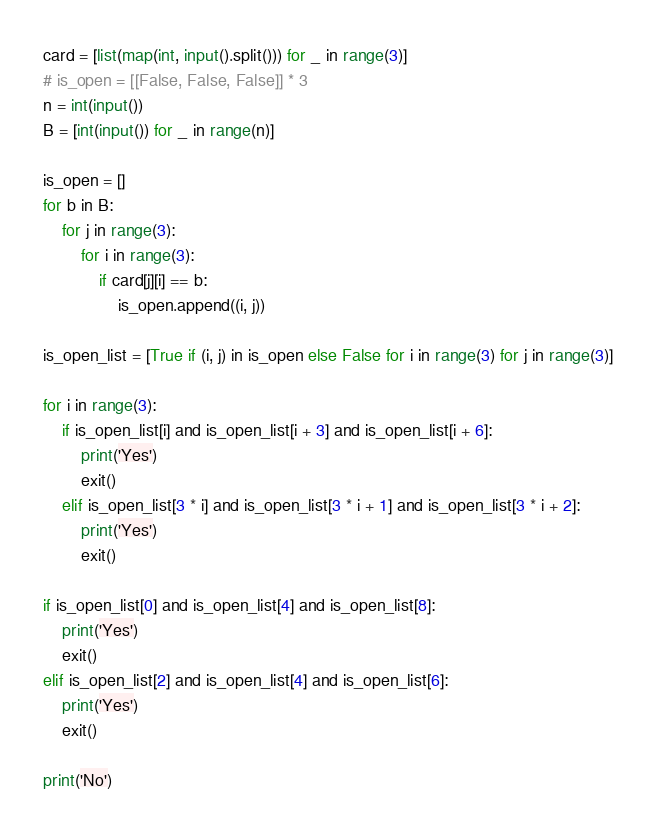<code> <loc_0><loc_0><loc_500><loc_500><_Python_>card = [list(map(int, input().split())) for _ in range(3)]
# is_open = [[False, False, False]] * 3
n = int(input())
B = [int(input()) for _ in range(n)]

is_open = []
for b in B:
    for j in range(3):
        for i in range(3):
            if card[j][i] == b:
                is_open.append((i, j))

is_open_list = [True if (i, j) in is_open else False for i in range(3) for j in range(3)]

for i in range(3):
    if is_open_list[i] and is_open_list[i + 3] and is_open_list[i + 6]:
        print('Yes')
        exit()
    elif is_open_list[3 * i] and is_open_list[3 * i + 1] and is_open_list[3 * i + 2]:
        print('Yes')
        exit()

if is_open_list[0] and is_open_list[4] and is_open_list[8]:
    print('Yes')
    exit()
elif is_open_list[2] and is_open_list[4] and is_open_list[6]:
    print('Yes')
    exit()

print('No')</code> 